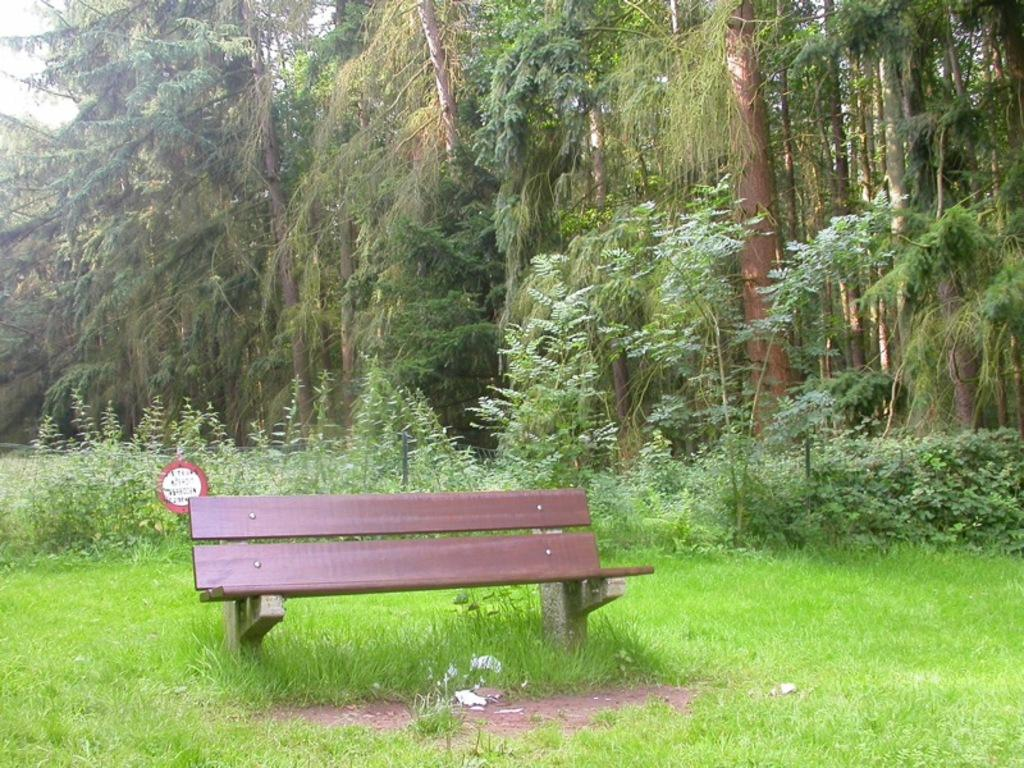What type of vegetation is at the bottom of the image? There is grass at the bottom of the image. What type of seating is in the middle of the image? There is a bench chair in the middle of the image. What can be seen in the background of the image? There are trees in the background of the image. How many children are holding tickets in the image? There are no children or tickets present in the image. What type of burn is visible on the bench chair in the image? There is no burn visible on the bench chair in the image. 